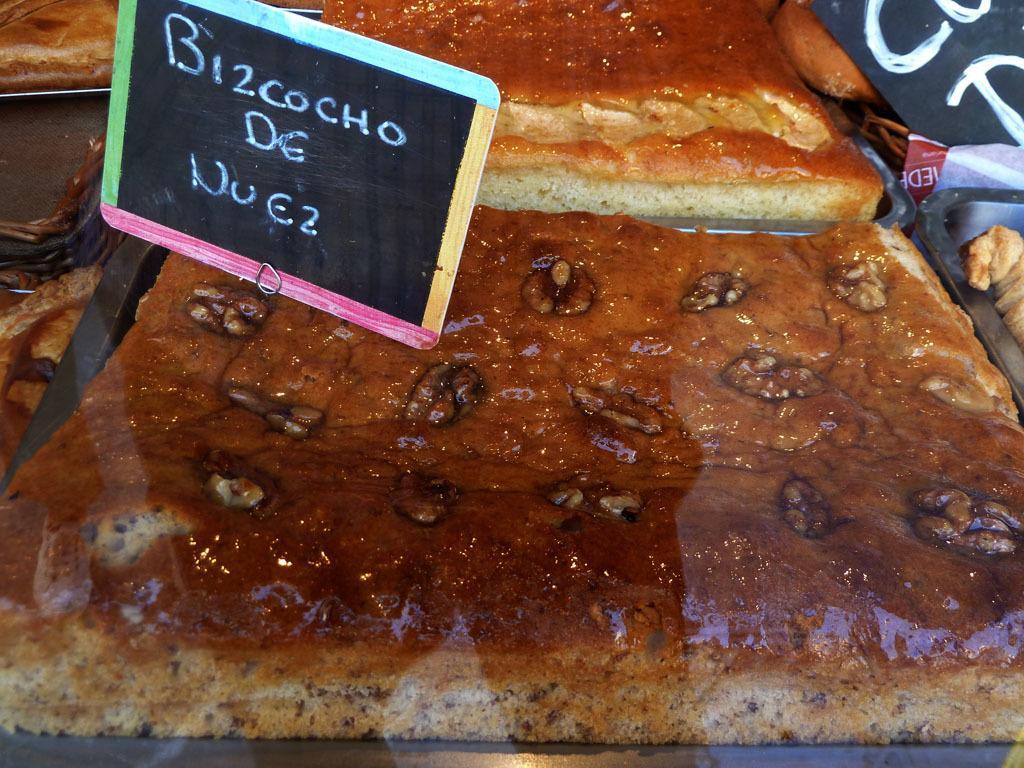How would you summarize this image in a sentence or two? In this image there are a few cakes on the trays and there is a board with a text on it. 